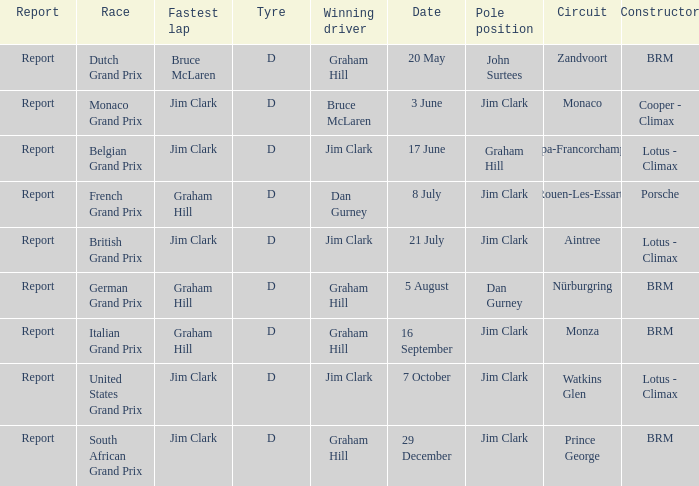What is the date of the circuit of nürburgring, which had Graham Hill as the winning driver? 5 August. 